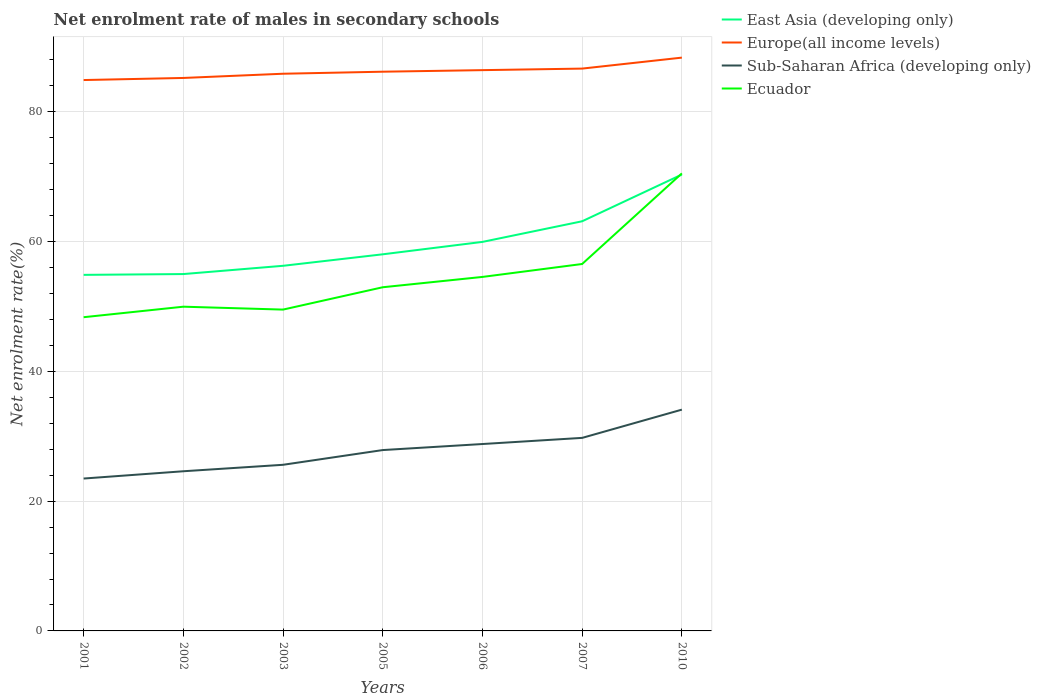How many different coloured lines are there?
Offer a terse response. 4. Does the line corresponding to Ecuador intersect with the line corresponding to East Asia (developing only)?
Make the answer very short. Yes. Across all years, what is the maximum net enrolment rate of males in secondary schools in Sub-Saharan Africa (developing only)?
Offer a very short reply. 23.49. In which year was the net enrolment rate of males in secondary schools in East Asia (developing only) maximum?
Offer a terse response. 2001. What is the total net enrolment rate of males in secondary schools in Europe(all income levels) in the graph?
Your answer should be very brief. -3.13. What is the difference between the highest and the second highest net enrolment rate of males in secondary schools in Ecuador?
Make the answer very short. 22.17. Is the net enrolment rate of males in secondary schools in Europe(all income levels) strictly greater than the net enrolment rate of males in secondary schools in Ecuador over the years?
Provide a succinct answer. No. How many years are there in the graph?
Offer a very short reply. 7. Does the graph contain grids?
Your response must be concise. Yes. How are the legend labels stacked?
Give a very brief answer. Vertical. What is the title of the graph?
Give a very brief answer. Net enrolment rate of males in secondary schools. Does "Heavily indebted poor countries" appear as one of the legend labels in the graph?
Provide a succinct answer. No. What is the label or title of the X-axis?
Make the answer very short. Years. What is the label or title of the Y-axis?
Provide a short and direct response. Net enrolment rate(%). What is the Net enrolment rate(%) of East Asia (developing only) in 2001?
Your answer should be compact. 54.88. What is the Net enrolment rate(%) of Europe(all income levels) in 2001?
Provide a succinct answer. 84.9. What is the Net enrolment rate(%) of Sub-Saharan Africa (developing only) in 2001?
Your response must be concise. 23.49. What is the Net enrolment rate(%) of Ecuador in 2001?
Offer a very short reply. 48.35. What is the Net enrolment rate(%) of East Asia (developing only) in 2002?
Your answer should be very brief. 55. What is the Net enrolment rate(%) in Europe(all income levels) in 2002?
Ensure brevity in your answer.  85.23. What is the Net enrolment rate(%) in Sub-Saharan Africa (developing only) in 2002?
Make the answer very short. 24.61. What is the Net enrolment rate(%) in Ecuador in 2002?
Provide a succinct answer. 49.97. What is the Net enrolment rate(%) in East Asia (developing only) in 2003?
Offer a very short reply. 56.28. What is the Net enrolment rate(%) of Europe(all income levels) in 2003?
Your answer should be very brief. 85.88. What is the Net enrolment rate(%) of Sub-Saharan Africa (developing only) in 2003?
Provide a short and direct response. 25.61. What is the Net enrolment rate(%) of Ecuador in 2003?
Provide a succinct answer. 49.53. What is the Net enrolment rate(%) in East Asia (developing only) in 2005?
Give a very brief answer. 58.05. What is the Net enrolment rate(%) of Europe(all income levels) in 2005?
Make the answer very short. 86.19. What is the Net enrolment rate(%) of Sub-Saharan Africa (developing only) in 2005?
Your response must be concise. 27.88. What is the Net enrolment rate(%) in Ecuador in 2005?
Provide a succinct answer. 52.97. What is the Net enrolment rate(%) of East Asia (developing only) in 2006?
Provide a succinct answer. 59.96. What is the Net enrolment rate(%) of Europe(all income levels) in 2006?
Your answer should be very brief. 86.43. What is the Net enrolment rate(%) in Sub-Saharan Africa (developing only) in 2006?
Your answer should be very brief. 28.81. What is the Net enrolment rate(%) of Ecuador in 2006?
Make the answer very short. 54.56. What is the Net enrolment rate(%) of East Asia (developing only) in 2007?
Your answer should be very brief. 63.14. What is the Net enrolment rate(%) of Europe(all income levels) in 2007?
Your response must be concise. 86.67. What is the Net enrolment rate(%) in Sub-Saharan Africa (developing only) in 2007?
Keep it short and to the point. 29.75. What is the Net enrolment rate(%) in Ecuador in 2007?
Keep it short and to the point. 56.56. What is the Net enrolment rate(%) of East Asia (developing only) in 2010?
Give a very brief answer. 70.34. What is the Net enrolment rate(%) of Europe(all income levels) in 2010?
Your answer should be very brief. 88.36. What is the Net enrolment rate(%) of Sub-Saharan Africa (developing only) in 2010?
Your answer should be very brief. 34.11. What is the Net enrolment rate(%) of Ecuador in 2010?
Provide a short and direct response. 70.52. Across all years, what is the maximum Net enrolment rate(%) in East Asia (developing only)?
Provide a succinct answer. 70.34. Across all years, what is the maximum Net enrolment rate(%) in Europe(all income levels)?
Your answer should be very brief. 88.36. Across all years, what is the maximum Net enrolment rate(%) of Sub-Saharan Africa (developing only)?
Keep it short and to the point. 34.11. Across all years, what is the maximum Net enrolment rate(%) in Ecuador?
Ensure brevity in your answer.  70.52. Across all years, what is the minimum Net enrolment rate(%) of East Asia (developing only)?
Ensure brevity in your answer.  54.88. Across all years, what is the minimum Net enrolment rate(%) in Europe(all income levels)?
Offer a terse response. 84.9. Across all years, what is the minimum Net enrolment rate(%) in Sub-Saharan Africa (developing only)?
Keep it short and to the point. 23.49. Across all years, what is the minimum Net enrolment rate(%) in Ecuador?
Ensure brevity in your answer.  48.35. What is the total Net enrolment rate(%) in East Asia (developing only) in the graph?
Your response must be concise. 417.65. What is the total Net enrolment rate(%) of Europe(all income levels) in the graph?
Ensure brevity in your answer.  603.67. What is the total Net enrolment rate(%) of Sub-Saharan Africa (developing only) in the graph?
Ensure brevity in your answer.  194.24. What is the total Net enrolment rate(%) of Ecuador in the graph?
Provide a succinct answer. 382.46. What is the difference between the Net enrolment rate(%) in East Asia (developing only) in 2001 and that in 2002?
Provide a short and direct response. -0.12. What is the difference between the Net enrolment rate(%) in Europe(all income levels) in 2001 and that in 2002?
Your answer should be very brief. -0.32. What is the difference between the Net enrolment rate(%) in Sub-Saharan Africa (developing only) in 2001 and that in 2002?
Your answer should be very brief. -1.12. What is the difference between the Net enrolment rate(%) of Ecuador in 2001 and that in 2002?
Your answer should be very brief. -1.62. What is the difference between the Net enrolment rate(%) in East Asia (developing only) in 2001 and that in 2003?
Your answer should be compact. -1.4. What is the difference between the Net enrolment rate(%) in Europe(all income levels) in 2001 and that in 2003?
Offer a terse response. -0.97. What is the difference between the Net enrolment rate(%) in Sub-Saharan Africa (developing only) in 2001 and that in 2003?
Keep it short and to the point. -2.12. What is the difference between the Net enrolment rate(%) in Ecuador in 2001 and that in 2003?
Make the answer very short. -1.17. What is the difference between the Net enrolment rate(%) in East Asia (developing only) in 2001 and that in 2005?
Give a very brief answer. -3.17. What is the difference between the Net enrolment rate(%) of Europe(all income levels) in 2001 and that in 2005?
Offer a terse response. -1.29. What is the difference between the Net enrolment rate(%) of Sub-Saharan Africa (developing only) in 2001 and that in 2005?
Your answer should be very brief. -4.39. What is the difference between the Net enrolment rate(%) in Ecuador in 2001 and that in 2005?
Provide a succinct answer. -4.62. What is the difference between the Net enrolment rate(%) of East Asia (developing only) in 2001 and that in 2006?
Your answer should be compact. -5.08. What is the difference between the Net enrolment rate(%) in Europe(all income levels) in 2001 and that in 2006?
Provide a succinct answer. -1.53. What is the difference between the Net enrolment rate(%) of Sub-Saharan Africa (developing only) in 2001 and that in 2006?
Offer a terse response. -5.32. What is the difference between the Net enrolment rate(%) in Ecuador in 2001 and that in 2006?
Your answer should be compact. -6.21. What is the difference between the Net enrolment rate(%) in East Asia (developing only) in 2001 and that in 2007?
Offer a terse response. -8.26. What is the difference between the Net enrolment rate(%) of Europe(all income levels) in 2001 and that in 2007?
Your answer should be very brief. -1.77. What is the difference between the Net enrolment rate(%) in Sub-Saharan Africa (developing only) in 2001 and that in 2007?
Provide a succinct answer. -6.27. What is the difference between the Net enrolment rate(%) of Ecuador in 2001 and that in 2007?
Keep it short and to the point. -8.2. What is the difference between the Net enrolment rate(%) in East Asia (developing only) in 2001 and that in 2010?
Keep it short and to the point. -15.46. What is the difference between the Net enrolment rate(%) in Europe(all income levels) in 2001 and that in 2010?
Offer a very short reply. -3.46. What is the difference between the Net enrolment rate(%) of Sub-Saharan Africa (developing only) in 2001 and that in 2010?
Provide a succinct answer. -10.62. What is the difference between the Net enrolment rate(%) in Ecuador in 2001 and that in 2010?
Your answer should be very brief. -22.17. What is the difference between the Net enrolment rate(%) of East Asia (developing only) in 2002 and that in 2003?
Provide a short and direct response. -1.27. What is the difference between the Net enrolment rate(%) of Europe(all income levels) in 2002 and that in 2003?
Your answer should be compact. -0.65. What is the difference between the Net enrolment rate(%) of Sub-Saharan Africa (developing only) in 2002 and that in 2003?
Offer a very short reply. -1. What is the difference between the Net enrolment rate(%) in Ecuador in 2002 and that in 2003?
Ensure brevity in your answer.  0.45. What is the difference between the Net enrolment rate(%) of East Asia (developing only) in 2002 and that in 2005?
Offer a very short reply. -3.04. What is the difference between the Net enrolment rate(%) in Europe(all income levels) in 2002 and that in 2005?
Your response must be concise. -0.96. What is the difference between the Net enrolment rate(%) in Sub-Saharan Africa (developing only) in 2002 and that in 2005?
Your response must be concise. -3.27. What is the difference between the Net enrolment rate(%) of Ecuador in 2002 and that in 2005?
Provide a succinct answer. -3. What is the difference between the Net enrolment rate(%) of East Asia (developing only) in 2002 and that in 2006?
Your answer should be compact. -4.96. What is the difference between the Net enrolment rate(%) in Europe(all income levels) in 2002 and that in 2006?
Provide a short and direct response. -1.2. What is the difference between the Net enrolment rate(%) in Sub-Saharan Africa (developing only) in 2002 and that in 2006?
Your answer should be compact. -4.2. What is the difference between the Net enrolment rate(%) of Ecuador in 2002 and that in 2006?
Your answer should be compact. -4.59. What is the difference between the Net enrolment rate(%) in East Asia (developing only) in 2002 and that in 2007?
Offer a very short reply. -8.14. What is the difference between the Net enrolment rate(%) in Europe(all income levels) in 2002 and that in 2007?
Keep it short and to the point. -1.44. What is the difference between the Net enrolment rate(%) of Sub-Saharan Africa (developing only) in 2002 and that in 2007?
Your answer should be compact. -5.15. What is the difference between the Net enrolment rate(%) of Ecuador in 2002 and that in 2007?
Your answer should be very brief. -6.58. What is the difference between the Net enrolment rate(%) of East Asia (developing only) in 2002 and that in 2010?
Make the answer very short. -15.34. What is the difference between the Net enrolment rate(%) of Europe(all income levels) in 2002 and that in 2010?
Ensure brevity in your answer.  -3.13. What is the difference between the Net enrolment rate(%) in Sub-Saharan Africa (developing only) in 2002 and that in 2010?
Ensure brevity in your answer.  -9.5. What is the difference between the Net enrolment rate(%) of Ecuador in 2002 and that in 2010?
Give a very brief answer. -20.55. What is the difference between the Net enrolment rate(%) in East Asia (developing only) in 2003 and that in 2005?
Your answer should be very brief. -1.77. What is the difference between the Net enrolment rate(%) in Europe(all income levels) in 2003 and that in 2005?
Your answer should be compact. -0.31. What is the difference between the Net enrolment rate(%) in Sub-Saharan Africa (developing only) in 2003 and that in 2005?
Your answer should be very brief. -2.27. What is the difference between the Net enrolment rate(%) of Ecuador in 2003 and that in 2005?
Make the answer very short. -3.44. What is the difference between the Net enrolment rate(%) of East Asia (developing only) in 2003 and that in 2006?
Your answer should be compact. -3.68. What is the difference between the Net enrolment rate(%) of Europe(all income levels) in 2003 and that in 2006?
Give a very brief answer. -0.55. What is the difference between the Net enrolment rate(%) of Sub-Saharan Africa (developing only) in 2003 and that in 2006?
Offer a very short reply. -3.2. What is the difference between the Net enrolment rate(%) in Ecuador in 2003 and that in 2006?
Provide a succinct answer. -5.04. What is the difference between the Net enrolment rate(%) in East Asia (developing only) in 2003 and that in 2007?
Keep it short and to the point. -6.86. What is the difference between the Net enrolment rate(%) in Europe(all income levels) in 2003 and that in 2007?
Provide a succinct answer. -0.79. What is the difference between the Net enrolment rate(%) in Sub-Saharan Africa (developing only) in 2003 and that in 2007?
Make the answer very short. -4.15. What is the difference between the Net enrolment rate(%) in Ecuador in 2003 and that in 2007?
Make the answer very short. -7.03. What is the difference between the Net enrolment rate(%) in East Asia (developing only) in 2003 and that in 2010?
Give a very brief answer. -14.07. What is the difference between the Net enrolment rate(%) of Europe(all income levels) in 2003 and that in 2010?
Make the answer very short. -2.48. What is the difference between the Net enrolment rate(%) in Sub-Saharan Africa (developing only) in 2003 and that in 2010?
Your response must be concise. -8.5. What is the difference between the Net enrolment rate(%) of Ecuador in 2003 and that in 2010?
Your answer should be compact. -20.99. What is the difference between the Net enrolment rate(%) of East Asia (developing only) in 2005 and that in 2006?
Your response must be concise. -1.91. What is the difference between the Net enrolment rate(%) in Europe(all income levels) in 2005 and that in 2006?
Your answer should be compact. -0.24. What is the difference between the Net enrolment rate(%) in Sub-Saharan Africa (developing only) in 2005 and that in 2006?
Ensure brevity in your answer.  -0.93. What is the difference between the Net enrolment rate(%) in Ecuador in 2005 and that in 2006?
Offer a terse response. -1.59. What is the difference between the Net enrolment rate(%) in East Asia (developing only) in 2005 and that in 2007?
Provide a succinct answer. -5.09. What is the difference between the Net enrolment rate(%) of Europe(all income levels) in 2005 and that in 2007?
Ensure brevity in your answer.  -0.48. What is the difference between the Net enrolment rate(%) in Sub-Saharan Africa (developing only) in 2005 and that in 2007?
Offer a terse response. -1.88. What is the difference between the Net enrolment rate(%) of Ecuador in 2005 and that in 2007?
Provide a short and direct response. -3.59. What is the difference between the Net enrolment rate(%) in East Asia (developing only) in 2005 and that in 2010?
Provide a short and direct response. -12.3. What is the difference between the Net enrolment rate(%) of Europe(all income levels) in 2005 and that in 2010?
Offer a very short reply. -2.17. What is the difference between the Net enrolment rate(%) in Sub-Saharan Africa (developing only) in 2005 and that in 2010?
Your answer should be compact. -6.23. What is the difference between the Net enrolment rate(%) in Ecuador in 2005 and that in 2010?
Your response must be concise. -17.55. What is the difference between the Net enrolment rate(%) of East Asia (developing only) in 2006 and that in 2007?
Your answer should be compact. -3.18. What is the difference between the Net enrolment rate(%) of Europe(all income levels) in 2006 and that in 2007?
Make the answer very short. -0.24. What is the difference between the Net enrolment rate(%) in Sub-Saharan Africa (developing only) in 2006 and that in 2007?
Offer a very short reply. -0.95. What is the difference between the Net enrolment rate(%) of Ecuador in 2006 and that in 2007?
Your answer should be compact. -1.99. What is the difference between the Net enrolment rate(%) of East Asia (developing only) in 2006 and that in 2010?
Make the answer very short. -10.38. What is the difference between the Net enrolment rate(%) of Europe(all income levels) in 2006 and that in 2010?
Keep it short and to the point. -1.93. What is the difference between the Net enrolment rate(%) in Sub-Saharan Africa (developing only) in 2006 and that in 2010?
Provide a succinct answer. -5.3. What is the difference between the Net enrolment rate(%) in Ecuador in 2006 and that in 2010?
Your answer should be compact. -15.96. What is the difference between the Net enrolment rate(%) of East Asia (developing only) in 2007 and that in 2010?
Your response must be concise. -7.2. What is the difference between the Net enrolment rate(%) of Europe(all income levels) in 2007 and that in 2010?
Offer a terse response. -1.69. What is the difference between the Net enrolment rate(%) in Sub-Saharan Africa (developing only) in 2007 and that in 2010?
Your answer should be very brief. -4.35. What is the difference between the Net enrolment rate(%) in Ecuador in 2007 and that in 2010?
Your answer should be compact. -13.96. What is the difference between the Net enrolment rate(%) of East Asia (developing only) in 2001 and the Net enrolment rate(%) of Europe(all income levels) in 2002?
Make the answer very short. -30.35. What is the difference between the Net enrolment rate(%) in East Asia (developing only) in 2001 and the Net enrolment rate(%) in Sub-Saharan Africa (developing only) in 2002?
Offer a terse response. 30.27. What is the difference between the Net enrolment rate(%) in East Asia (developing only) in 2001 and the Net enrolment rate(%) in Ecuador in 2002?
Offer a terse response. 4.91. What is the difference between the Net enrolment rate(%) in Europe(all income levels) in 2001 and the Net enrolment rate(%) in Sub-Saharan Africa (developing only) in 2002?
Offer a very short reply. 60.3. What is the difference between the Net enrolment rate(%) of Europe(all income levels) in 2001 and the Net enrolment rate(%) of Ecuador in 2002?
Your response must be concise. 34.93. What is the difference between the Net enrolment rate(%) in Sub-Saharan Africa (developing only) in 2001 and the Net enrolment rate(%) in Ecuador in 2002?
Provide a succinct answer. -26.49. What is the difference between the Net enrolment rate(%) in East Asia (developing only) in 2001 and the Net enrolment rate(%) in Europe(all income levels) in 2003?
Offer a terse response. -31. What is the difference between the Net enrolment rate(%) of East Asia (developing only) in 2001 and the Net enrolment rate(%) of Sub-Saharan Africa (developing only) in 2003?
Offer a terse response. 29.27. What is the difference between the Net enrolment rate(%) in East Asia (developing only) in 2001 and the Net enrolment rate(%) in Ecuador in 2003?
Keep it short and to the point. 5.35. What is the difference between the Net enrolment rate(%) of Europe(all income levels) in 2001 and the Net enrolment rate(%) of Sub-Saharan Africa (developing only) in 2003?
Keep it short and to the point. 59.3. What is the difference between the Net enrolment rate(%) in Europe(all income levels) in 2001 and the Net enrolment rate(%) in Ecuador in 2003?
Make the answer very short. 35.38. What is the difference between the Net enrolment rate(%) of Sub-Saharan Africa (developing only) in 2001 and the Net enrolment rate(%) of Ecuador in 2003?
Ensure brevity in your answer.  -26.04. What is the difference between the Net enrolment rate(%) in East Asia (developing only) in 2001 and the Net enrolment rate(%) in Europe(all income levels) in 2005?
Provide a short and direct response. -31.31. What is the difference between the Net enrolment rate(%) of East Asia (developing only) in 2001 and the Net enrolment rate(%) of Sub-Saharan Africa (developing only) in 2005?
Your response must be concise. 27. What is the difference between the Net enrolment rate(%) of East Asia (developing only) in 2001 and the Net enrolment rate(%) of Ecuador in 2005?
Make the answer very short. 1.91. What is the difference between the Net enrolment rate(%) in Europe(all income levels) in 2001 and the Net enrolment rate(%) in Sub-Saharan Africa (developing only) in 2005?
Your answer should be very brief. 57.03. What is the difference between the Net enrolment rate(%) in Europe(all income levels) in 2001 and the Net enrolment rate(%) in Ecuador in 2005?
Give a very brief answer. 31.94. What is the difference between the Net enrolment rate(%) in Sub-Saharan Africa (developing only) in 2001 and the Net enrolment rate(%) in Ecuador in 2005?
Your answer should be very brief. -29.48. What is the difference between the Net enrolment rate(%) of East Asia (developing only) in 2001 and the Net enrolment rate(%) of Europe(all income levels) in 2006?
Offer a very short reply. -31.55. What is the difference between the Net enrolment rate(%) in East Asia (developing only) in 2001 and the Net enrolment rate(%) in Sub-Saharan Africa (developing only) in 2006?
Offer a very short reply. 26.07. What is the difference between the Net enrolment rate(%) in East Asia (developing only) in 2001 and the Net enrolment rate(%) in Ecuador in 2006?
Give a very brief answer. 0.32. What is the difference between the Net enrolment rate(%) of Europe(all income levels) in 2001 and the Net enrolment rate(%) of Sub-Saharan Africa (developing only) in 2006?
Provide a succinct answer. 56.1. What is the difference between the Net enrolment rate(%) of Europe(all income levels) in 2001 and the Net enrolment rate(%) of Ecuador in 2006?
Offer a terse response. 30.34. What is the difference between the Net enrolment rate(%) of Sub-Saharan Africa (developing only) in 2001 and the Net enrolment rate(%) of Ecuador in 2006?
Your answer should be very brief. -31.08. What is the difference between the Net enrolment rate(%) in East Asia (developing only) in 2001 and the Net enrolment rate(%) in Europe(all income levels) in 2007?
Provide a short and direct response. -31.79. What is the difference between the Net enrolment rate(%) in East Asia (developing only) in 2001 and the Net enrolment rate(%) in Sub-Saharan Africa (developing only) in 2007?
Give a very brief answer. 25.13. What is the difference between the Net enrolment rate(%) in East Asia (developing only) in 2001 and the Net enrolment rate(%) in Ecuador in 2007?
Ensure brevity in your answer.  -1.68. What is the difference between the Net enrolment rate(%) of Europe(all income levels) in 2001 and the Net enrolment rate(%) of Sub-Saharan Africa (developing only) in 2007?
Offer a terse response. 55.15. What is the difference between the Net enrolment rate(%) in Europe(all income levels) in 2001 and the Net enrolment rate(%) in Ecuador in 2007?
Your answer should be compact. 28.35. What is the difference between the Net enrolment rate(%) in Sub-Saharan Africa (developing only) in 2001 and the Net enrolment rate(%) in Ecuador in 2007?
Offer a very short reply. -33.07. What is the difference between the Net enrolment rate(%) in East Asia (developing only) in 2001 and the Net enrolment rate(%) in Europe(all income levels) in 2010?
Ensure brevity in your answer.  -33.48. What is the difference between the Net enrolment rate(%) in East Asia (developing only) in 2001 and the Net enrolment rate(%) in Sub-Saharan Africa (developing only) in 2010?
Your response must be concise. 20.77. What is the difference between the Net enrolment rate(%) of East Asia (developing only) in 2001 and the Net enrolment rate(%) of Ecuador in 2010?
Keep it short and to the point. -15.64. What is the difference between the Net enrolment rate(%) of Europe(all income levels) in 2001 and the Net enrolment rate(%) of Sub-Saharan Africa (developing only) in 2010?
Ensure brevity in your answer.  50.8. What is the difference between the Net enrolment rate(%) of Europe(all income levels) in 2001 and the Net enrolment rate(%) of Ecuador in 2010?
Provide a short and direct response. 14.39. What is the difference between the Net enrolment rate(%) of Sub-Saharan Africa (developing only) in 2001 and the Net enrolment rate(%) of Ecuador in 2010?
Keep it short and to the point. -47.03. What is the difference between the Net enrolment rate(%) in East Asia (developing only) in 2002 and the Net enrolment rate(%) in Europe(all income levels) in 2003?
Offer a terse response. -30.88. What is the difference between the Net enrolment rate(%) of East Asia (developing only) in 2002 and the Net enrolment rate(%) of Sub-Saharan Africa (developing only) in 2003?
Your answer should be compact. 29.4. What is the difference between the Net enrolment rate(%) of East Asia (developing only) in 2002 and the Net enrolment rate(%) of Ecuador in 2003?
Your response must be concise. 5.48. What is the difference between the Net enrolment rate(%) in Europe(all income levels) in 2002 and the Net enrolment rate(%) in Sub-Saharan Africa (developing only) in 2003?
Your answer should be compact. 59.62. What is the difference between the Net enrolment rate(%) in Europe(all income levels) in 2002 and the Net enrolment rate(%) in Ecuador in 2003?
Provide a succinct answer. 35.7. What is the difference between the Net enrolment rate(%) of Sub-Saharan Africa (developing only) in 2002 and the Net enrolment rate(%) of Ecuador in 2003?
Make the answer very short. -24.92. What is the difference between the Net enrolment rate(%) of East Asia (developing only) in 2002 and the Net enrolment rate(%) of Europe(all income levels) in 2005?
Provide a short and direct response. -31.19. What is the difference between the Net enrolment rate(%) in East Asia (developing only) in 2002 and the Net enrolment rate(%) in Sub-Saharan Africa (developing only) in 2005?
Provide a succinct answer. 27.13. What is the difference between the Net enrolment rate(%) in East Asia (developing only) in 2002 and the Net enrolment rate(%) in Ecuador in 2005?
Keep it short and to the point. 2.03. What is the difference between the Net enrolment rate(%) of Europe(all income levels) in 2002 and the Net enrolment rate(%) of Sub-Saharan Africa (developing only) in 2005?
Provide a succinct answer. 57.35. What is the difference between the Net enrolment rate(%) of Europe(all income levels) in 2002 and the Net enrolment rate(%) of Ecuador in 2005?
Ensure brevity in your answer.  32.26. What is the difference between the Net enrolment rate(%) in Sub-Saharan Africa (developing only) in 2002 and the Net enrolment rate(%) in Ecuador in 2005?
Give a very brief answer. -28.36. What is the difference between the Net enrolment rate(%) of East Asia (developing only) in 2002 and the Net enrolment rate(%) of Europe(all income levels) in 2006?
Keep it short and to the point. -31.43. What is the difference between the Net enrolment rate(%) in East Asia (developing only) in 2002 and the Net enrolment rate(%) in Sub-Saharan Africa (developing only) in 2006?
Your answer should be compact. 26.2. What is the difference between the Net enrolment rate(%) of East Asia (developing only) in 2002 and the Net enrolment rate(%) of Ecuador in 2006?
Your answer should be very brief. 0.44. What is the difference between the Net enrolment rate(%) in Europe(all income levels) in 2002 and the Net enrolment rate(%) in Sub-Saharan Africa (developing only) in 2006?
Your answer should be compact. 56.42. What is the difference between the Net enrolment rate(%) of Europe(all income levels) in 2002 and the Net enrolment rate(%) of Ecuador in 2006?
Make the answer very short. 30.67. What is the difference between the Net enrolment rate(%) of Sub-Saharan Africa (developing only) in 2002 and the Net enrolment rate(%) of Ecuador in 2006?
Ensure brevity in your answer.  -29.95. What is the difference between the Net enrolment rate(%) in East Asia (developing only) in 2002 and the Net enrolment rate(%) in Europe(all income levels) in 2007?
Give a very brief answer. -31.67. What is the difference between the Net enrolment rate(%) of East Asia (developing only) in 2002 and the Net enrolment rate(%) of Sub-Saharan Africa (developing only) in 2007?
Ensure brevity in your answer.  25.25. What is the difference between the Net enrolment rate(%) of East Asia (developing only) in 2002 and the Net enrolment rate(%) of Ecuador in 2007?
Your answer should be very brief. -1.55. What is the difference between the Net enrolment rate(%) in Europe(all income levels) in 2002 and the Net enrolment rate(%) in Sub-Saharan Africa (developing only) in 2007?
Make the answer very short. 55.47. What is the difference between the Net enrolment rate(%) of Europe(all income levels) in 2002 and the Net enrolment rate(%) of Ecuador in 2007?
Make the answer very short. 28.67. What is the difference between the Net enrolment rate(%) of Sub-Saharan Africa (developing only) in 2002 and the Net enrolment rate(%) of Ecuador in 2007?
Your answer should be very brief. -31.95. What is the difference between the Net enrolment rate(%) in East Asia (developing only) in 2002 and the Net enrolment rate(%) in Europe(all income levels) in 2010?
Offer a very short reply. -33.36. What is the difference between the Net enrolment rate(%) in East Asia (developing only) in 2002 and the Net enrolment rate(%) in Sub-Saharan Africa (developing only) in 2010?
Make the answer very short. 20.9. What is the difference between the Net enrolment rate(%) in East Asia (developing only) in 2002 and the Net enrolment rate(%) in Ecuador in 2010?
Provide a short and direct response. -15.52. What is the difference between the Net enrolment rate(%) of Europe(all income levels) in 2002 and the Net enrolment rate(%) of Sub-Saharan Africa (developing only) in 2010?
Your answer should be compact. 51.12. What is the difference between the Net enrolment rate(%) of Europe(all income levels) in 2002 and the Net enrolment rate(%) of Ecuador in 2010?
Offer a very short reply. 14.71. What is the difference between the Net enrolment rate(%) in Sub-Saharan Africa (developing only) in 2002 and the Net enrolment rate(%) in Ecuador in 2010?
Give a very brief answer. -45.91. What is the difference between the Net enrolment rate(%) of East Asia (developing only) in 2003 and the Net enrolment rate(%) of Europe(all income levels) in 2005?
Your answer should be very brief. -29.92. What is the difference between the Net enrolment rate(%) of East Asia (developing only) in 2003 and the Net enrolment rate(%) of Sub-Saharan Africa (developing only) in 2005?
Offer a very short reply. 28.4. What is the difference between the Net enrolment rate(%) of East Asia (developing only) in 2003 and the Net enrolment rate(%) of Ecuador in 2005?
Give a very brief answer. 3.31. What is the difference between the Net enrolment rate(%) in Europe(all income levels) in 2003 and the Net enrolment rate(%) in Sub-Saharan Africa (developing only) in 2005?
Provide a succinct answer. 58. What is the difference between the Net enrolment rate(%) of Europe(all income levels) in 2003 and the Net enrolment rate(%) of Ecuador in 2005?
Your response must be concise. 32.91. What is the difference between the Net enrolment rate(%) of Sub-Saharan Africa (developing only) in 2003 and the Net enrolment rate(%) of Ecuador in 2005?
Your answer should be compact. -27.36. What is the difference between the Net enrolment rate(%) in East Asia (developing only) in 2003 and the Net enrolment rate(%) in Europe(all income levels) in 2006?
Ensure brevity in your answer.  -30.16. What is the difference between the Net enrolment rate(%) in East Asia (developing only) in 2003 and the Net enrolment rate(%) in Sub-Saharan Africa (developing only) in 2006?
Make the answer very short. 27.47. What is the difference between the Net enrolment rate(%) of East Asia (developing only) in 2003 and the Net enrolment rate(%) of Ecuador in 2006?
Give a very brief answer. 1.71. What is the difference between the Net enrolment rate(%) in Europe(all income levels) in 2003 and the Net enrolment rate(%) in Sub-Saharan Africa (developing only) in 2006?
Provide a succinct answer. 57.07. What is the difference between the Net enrolment rate(%) of Europe(all income levels) in 2003 and the Net enrolment rate(%) of Ecuador in 2006?
Provide a short and direct response. 31.32. What is the difference between the Net enrolment rate(%) in Sub-Saharan Africa (developing only) in 2003 and the Net enrolment rate(%) in Ecuador in 2006?
Your answer should be compact. -28.96. What is the difference between the Net enrolment rate(%) of East Asia (developing only) in 2003 and the Net enrolment rate(%) of Europe(all income levels) in 2007?
Your answer should be compact. -30.39. What is the difference between the Net enrolment rate(%) of East Asia (developing only) in 2003 and the Net enrolment rate(%) of Sub-Saharan Africa (developing only) in 2007?
Offer a very short reply. 26.52. What is the difference between the Net enrolment rate(%) of East Asia (developing only) in 2003 and the Net enrolment rate(%) of Ecuador in 2007?
Your answer should be compact. -0.28. What is the difference between the Net enrolment rate(%) in Europe(all income levels) in 2003 and the Net enrolment rate(%) in Sub-Saharan Africa (developing only) in 2007?
Your answer should be compact. 56.13. What is the difference between the Net enrolment rate(%) in Europe(all income levels) in 2003 and the Net enrolment rate(%) in Ecuador in 2007?
Your answer should be very brief. 29.32. What is the difference between the Net enrolment rate(%) of Sub-Saharan Africa (developing only) in 2003 and the Net enrolment rate(%) of Ecuador in 2007?
Offer a very short reply. -30.95. What is the difference between the Net enrolment rate(%) of East Asia (developing only) in 2003 and the Net enrolment rate(%) of Europe(all income levels) in 2010?
Keep it short and to the point. -32.09. What is the difference between the Net enrolment rate(%) of East Asia (developing only) in 2003 and the Net enrolment rate(%) of Sub-Saharan Africa (developing only) in 2010?
Your answer should be compact. 22.17. What is the difference between the Net enrolment rate(%) in East Asia (developing only) in 2003 and the Net enrolment rate(%) in Ecuador in 2010?
Provide a short and direct response. -14.24. What is the difference between the Net enrolment rate(%) in Europe(all income levels) in 2003 and the Net enrolment rate(%) in Sub-Saharan Africa (developing only) in 2010?
Your response must be concise. 51.77. What is the difference between the Net enrolment rate(%) in Europe(all income levels) in 2003 and the Net enrolment rate(%) in Ecuador in 2010?
Provide a succinct answer. 15.36. What is the difference between the Net enrolment rate(%) of Sub-Saharan Africa (developing only) in 2003 and the Net enrolment rate(%) of Ecuador in 2010?
Make the answer very short. -44.91. What is the difference between the Net enrolment rate(%) of East Asia (developing only) in 2005 and the Net enrolment rate(%) of Europe(all income levels) in 2006?
Ensure brevity in your answer.  -28.38. What is the difference between the Net enrolment rate(%) of East Asia (developing only) in 2005 and the Net enrolment rate(%) of Sub-Saharan Africa (developing only) in 2006?
Keep it short and to the point. 29.24. What is the difference between the Net enrolment rate(%) in East Asia (developing only) in 2005 and the Net enrolment rate(%) in Ecuador in 2006?
Offer a very short reply. 3.49. What is the difference between the Net enrolment rate(%) of Europe(all income levels) in 2005 and the Net enrolment rate(%) of Sub-Saharan Africa (developing only) in 2006?
Make the answer very short. 57.38. What is the difference between the Net enrolment rate(%) in Europe(all income levels) in 2005 and the Net enrolment rate(%) in Ecuador in 2006?
Offer a terse response. 31.63. What is the difference between the Net enrolment rate(%) in Sub-Saharan Africa (developing only) in 2005 and the Net enrolment rate(%) in Ecuador in 2006?
Give a very brief answer. -26.69. What is the difference between the Net enrolment rate(%) in East Asia (developing only) in 2005 and the Net enrolment rate(%) in Europe(all income levels) in 2007?
Make the answer very short. -28.62. What is the difference between the Net enrolment rate(%) of East Asia (developing only) in 2005 and the Net enrolment rate(%) of Sub-Saharan Africa (developing only) in 2007?
Your answer should be very brief. 28.29. What is the difference between the Net enrolment rate(%) in East Asia (developing only) in 2005 and the Net enrolment rate(%) in Ecuador in 2007?
Your answer should be compact. 1.49. What is the difference between the Net enrolment rate(%) of Europe(all income levels) in 2005 and the Net enrolment rate(%) of Sub-Saharan Africa (developing only) in 2007?
Keep it short and to the point. 56.44. What is the difference between the Net enrolment rate(%) in Europe(all income levels) in 2005 and the Net enrolment rate(%) in Ecuador in 2007?
Provide a succinct answer. 29.64. What is the difference between the Net enrolment rate(%) of Sub-Saharan Africa (developing only) in 2005 and the Net enrolment rate(%) of Ecuador in 2007?
Offer a very short reply. -28.68. What is the difference between the Net enrolment rate(%) of East Asia (developing only) in 2005 and the Net enrolment rate(%) of Europe(all income levels) in 2010?
Offer a terse response. -30.31. What is the difference between the Net enrolment rate(%) of East Asia (developing only) in 2005 and the Net enrolment rate(%) of Sub-Saharan Africa (developing only) in 2010?
Your answer should be compact. 23.94. What is the difference between the Net enrolment rate(%) of East Asia (developing only) in 2005 and the Net enrolment rate(%) of Ecuador in 2010?
Make the answer very short. -12.47. What is the difference between the Net enrolment rate(%) of Europe(all income levels) in 2005 and the Net enrolment rate(%) of Sub-Saharan Africa (developing only) in 2010?
Your answer should be compact. 52.08. What is the difference between the Net enrolment rate(%) in Europe(all income levels) in 2005 and the Net enrolment rate(%) in Ecuador in 2010?
Your answer should be very brief. 15.67. What is the difference between the Net enrolment rate(%) of Sub-Saharan Africa (developing only) in 2005 and the Net enrolment rate(%) of Ecuador in 2010?
Make the answer very short. -42.64. What is the difference between the Net enrolment rate(%) of East Asia (developing only) in 2006 and the Net enrolment rate(%) of Europe(all income levels) in 2007?
Offer a very short reply. -26.71. What is the difference between the Net enrolment rate(%) of East Asia (developing only) in 2006 and the Net enrolment rate(%) of Sub-Saharan Africa (developing only) in 2007?
Offer a terse response. 30.2. What is the difference between the Net enrolment rate(%) of East Asia (developing only) in 2006 and the Net enrolment rate(%) of Ecuador in 2007?
Make the answer very short. 3.4. What is the difference between the Net enrolment rate(%) in Europe(all income levels) in 2006 and the Net enrolment rate(%) in Sub-Saharan Africa (developing only) in 2007?
Keep it short and to the point. 56.68. What is the difference between the Net enrolment rate(%) of Europe(all income levels) in 2006 and the Net enrolment rate(%) of Ecuador in 2007?
Provide a short and direct response. 29.88. What is the difference between the Net enrolment rate(%) in Sub-Saharan Africa (developing only) in 2006 and the Net enrolment rate(%) in Ecuador in 2007?
Keep it short and to the point. -27.75. What is the difference between the Net enrolment rate(%) of East Asia (developing only) in 2006 and the Net enrolment rate(%) of Europe(all income levels) in 2010?
Make the answer very short. -28.4. What is the difference between the Net enrolment rate(%) of East Asia (developing only) in 2006 and the Net enrolment rate(%) of Sub-Saharan Africa (developing only) in 2010?
Give a very brief answer. 25.85. What is the difference between the Net enrolment rate(%) of East Asia (developing only) in 2006 and the Net enrolment rate(%) of Ecuador in 2010?
Make the answer very short. -10.56. What is the difference between the Net enrolment rate(%) of Europe(all income levels) in 2006 and the Net enrolment rate(%) of Sub-Saharan Africa (developing only) in 2010?
Your answer should be compact. 52.32. What is the difference between the Net enrolment rate(%) of Europe(all income levels) in 2006 and the Net enrolment rate(%) of Ecuador in 2010?
Your response must be concise. 15.91. What is the difference between the Net enrolment rate(%) of Sub-Saharan Africa (developing only) in 2006 and the Net enrolment rate(%) of Ecuador in 2010?
Your answer should be very brief. -41.71. What is the difference between the Net enrolment rate(%) in East Asia (developing only) in 2007 and the Net enrolment rate(%) in Europe(all income levels) in 2010?
Keep it short and to the point. -25.22. What is the difference between the Net enrolment rate(%) in East Asia (developing only) in 2007 and the Net enrolment rate(%) in Sub-Saharan Africa (developing only) in 2010?
Provide a short and direct response. 29.03. What is the difference between the Net enrolment rate(%) in East Asia (developing only) in 2007 and the Net enrolment rate(%) in Ecuador in 2010?
Keep it short and to the point. -7.38. What is the difference between the Net enrolment rate(%) in Europe(all income levels) in 2007 and the Net enrolment rate(%) in Sub-Saharan Africa (developing only) in 2010?
Ensure brevity in your answer.  52.56. What is the difference between the Net enrolment rate(%) of Europe(all income levels) in 2007 and the Net enrolment rate(%) of Ecuador in 2010?
Offer a very short reply. 16.15. What is the difference between the Net enrolment rate(%) in Sub-Saharan Africa (developing only) in 2007 and the Net enrolment rate(%) in Ecuador in 2010?
Ensure brevity in your answer.  -40.77. What is the average Net enrolment rate(%) of East Asia (developing only) per year?
Your answer should be compact. 59.66. What is the average Net enrolment rate(%) in Europe(all income levels) per year?
Your answer should be compact. 86.24. What is the average Net enrolment rate(%) of Sub-Saharan Africa (developing only) per year?
Make the answer very short. 27.75. What is the average Net enrolment rate(%) of Ecuador per year?
Provide a succinct answer. 54.64. In the year 2001, what is the difference between the Net enrolment rate(%) in East Asia (developing only) and Net enrolment rate(%) in Europe(all income levels)?
Keep it short and to the point. -30.03. In the year 2001, what is the difference between the Net enrolment rate(%) in East Asia (developing only) and Net enrolment rate(%) in Sub-Saharan Africa (developing only)?
Provide a short and direct response. 31.39. In the year 2001, what is the difference between the Net enrolment rate(%) in East Asia (developing only) and Net enrolment rate(%) in Ecuador?
Keep it short and to the point. 6.53. In the year 2001, what is the difference between the Net enrolment rate(%) in Europe(all income levels) and Net enrolment rate(%) in Sub-Saharan Africa (developing only)?
Give a very brief answer. 61.42. In the year 2001, what is the difference between the Net enrolment rate(%) of Europe(all income levels) and Net enrolment rate(%) of Ecuador?
Provide a short and direct response. 36.55. In the year 2001, what is the difference between the Net enrolment rate(%) in Sub-Saharan Africa (developing only) and Net enrolment rate(%) in Ecuador?
Offer a terse response. -24.87. In the year 2002, what is the difference between the Net enrolment rate(%) in East Asia (developing only) and Net enrolment rate(%) in Europe(all income levels)?
Make the answer very short. -30.23. In the year 2002, what is the difference between the Net enrolment rate(%) in East Asia (developing only) and Net enrolment rate(%) in Sub-Saharan Africa (developing only)?
Make the answer very short. 30.39. In the year 2002, what is the difference between the Net enrolment rate(%) in East Asia (developing only) and Net enrolment rate(%) in Ecuador?
Your answer should be very brief. 5.03. In the year 2002, what is the difference between the Net enrolment rate(%) in Europe(all income levels) and Net enrolment rate(%) in Sub-Saharan Africa (developing only)?
Your response must be concise. 60.62. In the year 2002, what is the difference between the Net enrolment rate(%) in Europe(all income levels) and Net enrolment rate(%) in Ecuador?
Keep it short and to the point. 35.25. In the year 2002, what is the difference between the Net enrolment rate(%) in Sub-Saharan Africa (developing only) and Net enrolment rate(%) in Ecuador?
Provide a short and direct response. -25.36. In the year 2003, what is the difference between the Net enrolment rate(%) of East Asia (developing only) and Net enrolment rate(%) of Europe(all income levels)?
Your answer should be compact. -29.6. In the year 2003, what is the difference between the Net enrolment rate(%) of East Asia (developing only) and Net enrolment rate(%) of Sub-Saharan Africa (developing only)?
Offer a terse response. 30.67. In the year 2003, what is the difference between the Net enrolment rate(%) in East Asia (developing only) and Net enrolment rate(%) in Ecuador?
Ensure brevity in your answer.  6.75. In the year 2003, what is the difference between the Net enrolment rate(%) of Europe(all income levels) and Net enrolment rate(%) of Sub-Saharan Africa (developing only)?
Give a very brief answer. 60.27. In the year 2003, what is the difference between the Net enrolment rate(%) in Europe(all income levels) and Net enrolment rate(%) in Ecuador?
Ensure brevity in your answer.  36.35. In the year 2003, what is the difference between the Net enrolment rate(%) of Sub-Saharan Africa (developing only) and Net enrolment rate(%) of Ecuador?
Offer a very short reply. -23.92. In the year 2005, what is the difference between the Net enrolment rate(%) in East Asia (developing only) and Net enrolment rate(%) in Europe(all income levels)?
Provide a short and direct response. -28.14. In the year 2005, what is the difference between the Net enrolment rate(%) in East Asia (developing only) and Net enrolment rate(%) in Sub-Saharan Africa (developing only)?
Provide a succinct answer. 30.17. In the year 2005, what is the difference between the Net enrolment rate(%) in East Asia (developing only) and Net enrolment rate(%) in Ecuador?
Provide a succinct answer. 5.08. In the year 2005, what is the difference between the Net enrolment rate(%) in Europe(all income levels) and Net enrolment rate(%) in Sub-Saharan Africa (developing only)?
Provide a short and direct response. 58.32. In the year 2005, what is the difference between the Net enrolment rate(%) of Europe(all income levels) and Net enrolment rate(%) of Ecuador?
Give a very brief answer. 33.22. In the year 2005, what is the difference between the Net enrolment rate(%) in Sub-Saharan Africa (developing only) and Net enrolment rate(%) in Ecuador?
Offer a very short reply. -25.09. In the year 2006, what is the difference between the Net enrolment rate(%) of East Asia (developing only) and Net enrolment rate(%) of Europe(all income levels)?
Offer a terse response. -26.47. In the year 2006, what is the difference between the Net enrolment rate(%) in East Asia (developing only) and Net enrolment rate(%) in Sub-Saharan Africa (developing only)?
Provide a succinct answer. 31.15. In the year 2006, what is the difference between the Net enrolment rate(%) in East Asia (developing only) and Net enrolment rate(%) in Ecuador?
Your answer should be very brief. 5.4. In the year 2006, what is the difference between the Net enrolment rate(%) of Europe(all income levels) and Net enrolment rate(%) of Sub-Saharan Africa (developing only)?
Offer a very short reply. 57.63. In the year 2006, what is the difference between the Net enrolment rate(%) in Europe(all income levels) and Net enrolment rate(%) in Ecuador?
Ensure brevity in your answer.  31.87. In the year 2006, what is the difference between the Net enrolment rate(%) in Sub-Saharan Africa (developing only) and Net enrolment rate(%) in Ecuador?
Keep it short and to the point. -25.75. In the year 2007, what is the difference between the Net enrolment rate(%) of East Asia (developing only) and Net enrolment rate(%) of Europe(all income levels)?
Offer a very short reply. -23.53. In the year 2007, what is the difference between the Net enrolment rate(%) in East Asia (developing only) and Net enrolment rate(%) in Sub-Saharan Africa (developing only)?
Your response must be concise. 33.39. In the year 2007, what is the difference between the Net enrolment rate(%) of East Asia (developing only) and Net enrolment rate(%) of Ecuador?
Give a very brief answer. 6.58. In the year 2007, what is the difference between the Net enrolment rate(%) of Europe(all income levels) and Net enrolment rate(%) of Sub-Saharan Africa (developing only)?
Make the answer very short. 56.92. In the year 2007, what is the difference between the Net enrolment rate(%) of Europe(all income levels) and Net enrolment rate(%) of Ecuador?
Offer a very short reply. 30.12. In the year 2007, what is the difference between the Net enrolment rate(%) in Sub-Saharan Africa (developing only) and Net enrolment rate(%) in Ecuador?
Give a very brief answer. -26.8. In the year 2010, what is the difference between the Net enrolment rate(%) of East Asia (developing only) and Net enrolment rate(%) of Europe(all income levels)?
Make the answer very short. -18.02. In the year 2010, what is the difference between the Net enrolment rate(%) of East Asia (developing only) and Net enrolment rate(%) of Sub-Saharan Africa (developing only)?
Make the answer very short. 36.24. In the year 2010, what is the difference between the Net enrolment rate(%) of East Asia (developing only) and Net enrolment rate(%) of Ecuador?
Keep it short and to the point. -0.18. In the year 2010, what is the difference between the Net enrolment rate(%) of Europe(all income levels) and Net enrolment rate(%) of Sub-Saharan Africa (developing only)?
Your response must be concise. 54.25. In the year 2010, what is the difference between the Net enrolment rate(%) in Europe(all income levels) and Net enrolment rate(%) in Ecuador?
Make the answer very short. 17.84. In the year 2010, what is the difference between the Net enrolment rate(%) of Sub-Saharan Africa (developing only) and Net enrolment rate(%) of Ecuador?
Keep it short and to the point. -36.41. What is the ratio of the Net enrolment rate(%) of East Asia (developing only) in 2001 to that in 2002?
Your response must be concise. 1. What is the ratio of the Net enrolment rate(%) of Europe(all income levels) in 2001 to that in 2002?
Keep it short and to the point. 1. What is the ratio of the Net enrolment rate(%) in Sub-Saharan Africa (developing only) in 2001 to that in 2002?
Your response must be concise. 0.95. What is the ratio of the Net enrolment rate(%) of Ecuador in 2001 to that in 2002?
Offer a very short reply. 0.97. What is the ratio of the Net enrolment rate(%) of East Asia (developing only) in 2001 to that in 2003?
Keep it short and to the point. 0.98. What is the ratio of the Net enrolment rate(%) in Europe(all income levels) in 2001 to that in 2003?
Offer a very short reply. 0.99. What is the ratio of the Net enrolment rate(%) in Sub-Saharan Africa (developing only) in 2001 to that in 2003?
Ensure brevity in your answer.  0.92. What is the ratio of the Net enrolment rate(%) in Ecuador in 2001 to that in 2003?
Ensure brevity in your answer.  0.98. What is the ratio of the Net enrolment rate(%) in East Asia (developing only) in 2001 to that in 2005?
Offer a terse response. 0.95. What is the ratio of the Net enrolment rate(%) in Europe(all income levels) in 2001 to that in 2005?
Keep it short and to the point. 0.99. What is the ratio of the Net enrolment rate(%) of Sub-Saharan Africa (developing only) in 2001 to that in 2005?
Offer a very short reply. 0.84. What is the ratio of the Net enrolment rate(%) of Ecuador in 2001 to that in 2005?
Provide a short and direct response. 0.91. What is the ratio of the Net enrolment rate(%) in East Asia (developing only) in 2001 to that in 2006?
Keep it short and to the point. 0.92. What is the ratio of the Net enrolment rate(%) of Europe(all income levels) in 2001 to that in 2006?
Give a very brief answer. 0.98. What is the ratio of the Net enrolment rate(%) of Sub-Saharan Africa (developing only) in 2001 to that in 2006?
Make the answer very short. 0.82. What is the ratio of the Net enrolment rate(%) in Ecuador in 2001 to that in 2006?
Provide a short and direct response. 0.89. What is the ratio of the Net enrolment rate(%) of East Asia (developing only) in 2001 to that in 2007?
Offer a very short reply. 0.87. What is the ratio of the Net enrolment rate(%) in Europe(all income levels) in 2001 to that in 2007?
Provide a short and direct response. 0.98. What is the ratio of the Net enrolment rate(%) in Sub-Saharan Africa (developing only) in 2001 to that in 2007?
Offer a terse response. 0.79. What is the ratio of the Net enrolment rate(%) in Ecuador in 2001 to that in 2007?
Your answer should be very brief. 0.85. What is the ratio of the Net enrolment rate(%) in East Asia (developing only) in 2001 to that in 2010?
Offer a very short reply. 0.78. What is the ratio of the Net enrolment rate(%) of Europe(all income levels) in 2001 to that in 2010?
Offer a very short reply. 0.96. What is the ratio of the Net enrolment rate(%) of Sub-Saharan Africa (developing only) in 2001 to that in 2010?
Provide a short and direct response. 0.69. What is the ratio of the Net enrolment rate(%) of Ecuador in 2001 to that in 2010?
Offer a very short reply. 0.69. What is the ratio of the Net enrolment rate(%) of East Asia (developing only) in 2002 to that in 2003?
Ensure brevity in your answer.  0.98. What is the ratio of the Net enrolment rate(%) of Sub-Saharan Africa (developing only) in 2002 to that in 2003?
Provide a succinct answer. 0.96. What is the ratio of the Net enrolment rate(%) in Ecuador in 2002 to that in 2003?
Offer a terse response. 1.01. What is the ratio of the Net enrolment rate(%) of East Asia (developing only) in 2002 to that in 2005?
Your answer should be compact. 0.95. What is the ratio of the Net enrolment rate(%) of Sub-Saharan Africa (developing only) in 2002 to that in 2005?
Make the answer very short. 0.88. What is the ratio of the Net enrolment rate(%) of Ecuador in 2002 to that in 2005?
Provide a short and direct response. 0.94. What is the ratio of the Net enrolment rate(%) in East Asia (developing only) in 2002 to that in 2006?
Make the answer very short. 0.92. What is the ratio of the Net enrolment rate(%) in Europe(all income levels) in 2002 to that in 2006?
Offer a terse response. 0.99. What is the ratio of the Net enrolment rate(%) of Sub-Saharan Africa (developing only) in 2002 to that in 2006?
Provide a short and direct response. 0.85. What is the ratio of the Net enrolment rate(%) of Ecuador in 2002 to that in 2006?
Ensure brevity in your answer.  0.92. What is the ratio of the Net enrolment rate(%) in East Asia (developing only) in 2002 to that in 2007?
Provide a succinct answer. 0.87. What is the ratio of the Net enrolment rate(%) in Europe(all income levels) in 2002 to that in 2007?
Keep it short and to the point. 0.98. What is the ratio of the Net enrolment rate(%) in Sub-Saharan Africa (developing only) in 2002 to that in 2007?
Ensure brevity in your answer.  0.83. What is the ratio of the Net enrolment rate(%) of Ecuador in 2002 to that in 2007?
Your response must be concise. 0.88. What is the ratio of the Net enrolment rate(%) of East Asia (developing only) in 2002 to that in 2010?
Your answer should be very brief. 0.78. What is the ratio of the Net enrolment rate(%) in Europe(all income levels) in 2002 to that in 2010?
Your response must be concise. 0.96. What is the ratio of the Net enrolment rate(%) of Sub-Saharan Africa (developing only) in 2002 to that in 2010?
Make the answer very short. 0.72. What is the ratio of the Net enrolment rate(%) of Ecuador in 2002 to that in 2010?
Provide a succinct answer. 0.71. What is the ratio of the Net enrolment rate(%) in East Asia (developing only) in 2003 to that in 2005?
Offer a very short reply. 0.97. What is the ratio of the Net enrolment rate(%) in Sub-Saharan Africa (developing only) in 2003 to that in 2005?
Your answer should be very brief. 0.92. What is the ratio of the Net enrolment rate(%) in Ecuador in 2003 to that in 2005?
Provide a succinct answer. 0.94. What is the ratio of the Net enrolment rate(%) of East Asia (developing only) in 2003 to that in 2006?
Keep it short and to the point. 0.94. What is the ratio of the Net enrolment rate(%) of Europe(all income levels) in 2003 to that in 2006?
Offer a very short reply. 0.99. What is the ratio of the Net enrolment rate(%) of Ecuador in 2003 to that in 2006?
Provide a short and direct response. 0.91. What is the ratio of the Net enrolment rate(%) of East Asia (developing only) in 2003 to that in 2007?
Give a very brief answer. 0.89. What is the ratio of the Net enrolment rate(%) of Europe(all income levels) in 2003 to that in 2007?
Offer a terse response. 0.99. What is the ratio of the Net enrolment rate(%) of Sub-Saharan Africa (developing only) in 2003 to that in 2007?
Your answer should be compact. 0.86. What is the ratio of the Net enrolment rate(%) of Ecuador in 2003 to that in 2007?
Your answer should be very brief. 0.88. What is the ratio of the Net enrolment rate(%) of East Asia (developing only) in 2003 to that in 2010?
Provide a succinct answer. 0.8. What is the ratio of the Net enrolment rate(%) in Europe(all income levels) in 2003 to that in 2010?
Provide a short and direct response. 0.97. What is the ratio of the Net enrolment rate(%) in Sub-Saharan Africa (developing only) in 2003 to that in 2010?
Provide a succinct answer. 0.75. What is the ratio of the Net enrolment rate(%) in Ecuador in 2003 to that in 2010?
Make the answer very short. 0.7. What is the ratio of the Net enrolment rate(%) in East Asia (developing only) in 2005 to that in 2006?
Ensure brevity in your answer.  0.97. What is the ratio of the Net enrolment rate(%) in Sub-Saharan Africa (developing only) in 2005 to that in 2006?
Keep it short and to the point. 0.97. What is the ratio of the Net enrolment rate(%) in Ecuador in 2005 to that in 2006?
Offer a very short reply. 0.97. What is the ratio of the Net enrolment rate(%) in East Asia (developing only) in 2005 to that in 2007?
Offer a terse response. 0.92. What is the ratio of the Net enrolment rate(%) of Sub-Saharan Africa (developing only) in 2005 to that in 2007?
Provide a succinct answer. 0.94. What is the ratio of the Net enrolment rate(%) of Ecuador in 2005 to that in 2007?
Ensure brevity in your answer.  0.94. What is the ratio of the Net enrolment rate(%) of East Asia (developing only) in 2005 to that in 2010?
Provide a succinct answer. 0.83. What is the ratio of the Net enrolment rate(%) of Europe(all income levels) in 2005 to that in 2010?
Offer a terse response. 0.98. What is the ratio of the Net enrolment rate(%) of Sub-Saharan Africa (developing only) in 2005 to that in 2010?
Provide a short and direct response. 0.82. What is the ratio of the Net enrolment rate(%) in Ecuador in 2005 to that in 2010?
Your answer should be very brief. 0.75. What is the ratio of the Net enrolment rate(%) of East Asia (developing only) in 2006 to that in 2007?
Make the answer very short. 0.95. What is the ratio of the Net enrolment rate(%) in Europe(all income levels) in 2006 to that in 2007?
Your response must be concise. 1. What is the ratio of the Net enrolment rate(%) of Sub-Saharan Africa (developing only) in 2006 to that in 2007?
Keep it short and to the point. 0.97. What is the ratio of the Net enrolment rate(%) of Ecuador in 2006 to that in 2007?
Offer a terse response. 0.96. What is the ratio of the Net enrolment rate(%) of East Asia (developing only) in 2006 to that in 2010?
Your response must be concise. 0.85. What is the ratio of the Net enrolment rate(%) in Europe(all income levels) in 2006 to that in 2010?
Make the answer very short. 0.98. What is the ratio of the Net enrolment rate(%) in Sub-Saharan Africa (developing only) in 2006 to that in 2010?
Offer a very short reply. 0.84. What is the ratio of the Net enrolment rate(%) of Ecuador in 2006 to that in 2010?
Keep it short and to the point. 0.77. What is the ratio of the Net enrolment rate(%) in East Asia (developing only) in 2007 to that in 2010?
Your answer should be compact. 0.9. What is the ratio of the Net enrolment rate(%) of Europe(all income levels) in 2007 to that in 2010?
Ensure brevity in your answer.  0.98. What is the ratio of the Net enrolment rate(%) of Sub-Saharan Africa (developing only) in 2007 to that in 2010?
Give a very brief answer. 0.87. What is the ratio of the Net enrolment rate(%) in Ecuador in 2007 to that in 2010?
Give a very brief answer. 0.8. What is the difference between the highest and the second highest Net enrolment rate(%) of East Asia (developing only)?
Your answer should be very brief. 7.2. What is the difference between the highest and the second highest Net enrolment rate(%) in Europe(all income levels)?
Keep it short and to the point. 1.69. What is the difference between the highest and the second highest Net enrolment rate(%) in Sub-Saharan Africa (developing only)?
Ensure brevity in your answer.  4.35. What is the difference between the highest and the second highest Net enrolment rate(%) of Ecuador?
Give a very brief answer. 13.96. What is the difference between the highest and the lowest Net enrolment rate(%) in East Asia (developing only)?
Make the answer very short. 15.46. What is the difference between the highest and the lowest Net enrolment rate(%) of Europe(all income levels)?
Your answer should be very brief. 3.46. What is the difference between the highest and the lowest Net enrolment rate(%) of Sub-Saharan Africa (developing only)?
Give a very brief answer. 10.62. What is the difference between the highest and the lowest Net enrolment rate(%) of Ecuador?
Your answer should be very brief. 22.17. 